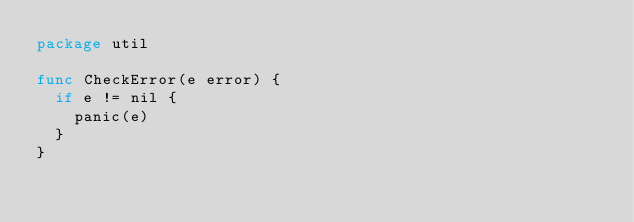Convert code to text. <code><loc_0><loc_0><loc_500><loc_500><_Go_>package util

func CheckError(e error) {
	if e != nil {
		panic(e)
	}
}
</code> 